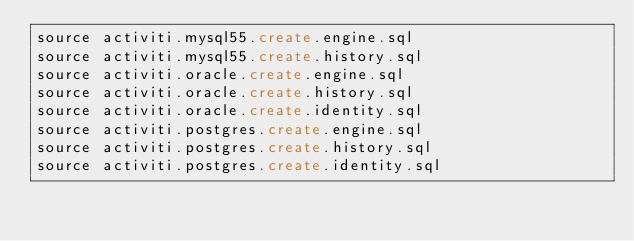<code> <loc_0><loc_0><loc_500><loc_500><_SQL_>source activiti.mysql55.create.engine.sql
source activiti.mysql55.create.history.sql
source activiti.oracle.create.engine.sql
source activiti.oracle.create.history.sql
source activiti.oracle.create.identity.sql
source activiti.postgres.create.engine.sql
source activiti.postgres.create.history.sql
source activiti.postgres.create.identity.sql</code> 